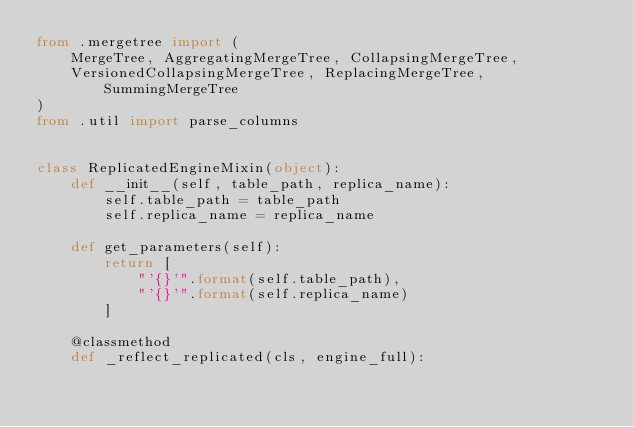Convert code to text. <code><loc_0><loc_0><loc_500><loc_500><_Python_>from .mergetree import (
    MergeTree, AggregatingMergeTree, CollapsingMergeTree,
    VersionedCollapsingMergeTree, ReplacingMergeTree, SummingMergeTree
)
from .util import parse_columns


class ReplicatedEngineMixin(object):
    def __init__(self, table_path, replica_name):
        self.table_path = table_path
        self.replica_name = replica_name

    def get_parameters(self):
        return [
            "'{}'".format(self.table_path),
            "'{}'".format(self.replica_name)
        ]

    @classmethod
    def _reflect_replicated(cls, engine_full):</code> 